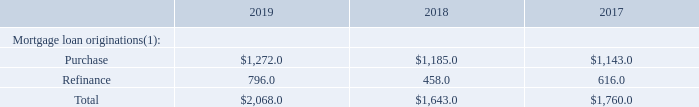Overview of the Markets We Serve
The U.S. mortgage loan servicing market is comprised of first and second lien mortgage loans. Even through housing downturns, the mortgage loan servicing market generally remains stable, as the total number of first lien mortgage loans outstanding tends to stay relatively constant. The number of second lien mortgage loans outstanding can vary based on a number of factors including loan-to-value ratios, interest rates and lenders' desire to own such loans.
While delinquent mortgage loans typically represent a small portion of the overall mortgage loan servicing market, the mortgage loan default process is long and complex and involves multiple parties, a significant exchange of data and documentation and extensive regulatory requirements. Providers in the default process must be able to meet strict regulatory guidelines, which we believe are best met through the use of proven technology.
The U.S. mortgage loan origination market consists of both purchase and refinance mortgage loan originations. The mortgage loan origination process is complex and involves multiple parties, significant data exchange and significant regulatory oversight, which requires a comprehensive, scalable solution developed by a company with substantial industry experience. According to the Mortgage Bankers Association ("MBA"), the U.S. mortgage loan origination market for purchase and refinance mortgage loan originations is estimated as follows (in billions):
Note: Amounts may not recalculate due to rounding.
(1) The 2019, 2018 and 2017 U.S. mortgage loan origination market for purchase and refinance originations is estimated by the MBA Mortgage Finance Forecast as of February 18, 2020, February 11, 2019 and October 16, 2018, respectively.
By whom was the U.S. mortgage loan origination market for purchase and refinance originations estimated by? Mba mortgage finance forecast. What was the mortgage loan originations for purchase originations in 2018?
Answer scale should be: billion. 1,185.0. Which years does the table provide information for the  U.S. mortgage loan origination market for purchase and refinance mortgage loan originations? 2019, 2018, 2017. What was the change in the refinance originations between 2017 and 2018?
Answer scale should be: billion. 458.0-616.0
Answer: -158. How many years did the purchase originations exceed $1,000 billion? 2019##2018##2017
Answer: 3. What was the percentage change in the total Mortgage loan originations between 2018 and 2019?
Answer scale should be: percent. (2,068.0-1,643.0)/1,643.0
Answer: 25.87. 